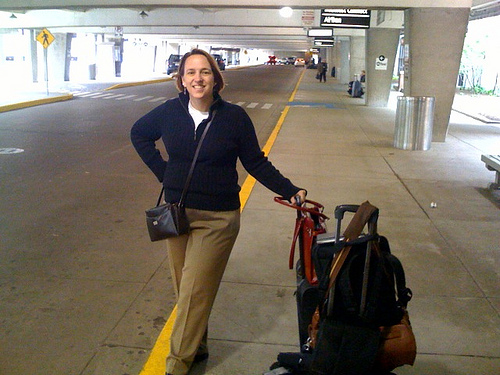Create a detailed backstory for the woman in the image. The woman in the image is named Sarah. She works as an international journalist who covers humanitarian stories. Sarah has spent the last three months in a rural village documenting the lives of its residents. Now, she is on her way to another destination to cover a crucial story about environmental conservation efforts. Her bag is filled with notebooks, recording devices, and essential travel gear. Her journey has seen her navigate through challenging terrains and encounter various cultures, each enriching her perspective and strengthening her resolve to bring untold stories to the world. As she moves from one location to another, her experiences not only enhance her career but also deepen her understanding of the global tapestry of human experiences. What are some challenges she might face during her travels? Sarah may face numerous challenges, such as navigating through regions with political unrest, dealing with the logistical hurdles of remote travel, and ensuring her physical safety while on assignment. Additionally, she might encounter language barriers and cultural nuances that require her to adapt quickly. Despite these obstacles, her passion for storytelling and commitment to shedding light on crucial issues drives her forward. 